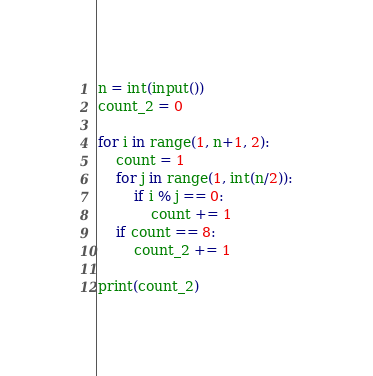<code> <loc_0><loc_0><loc_500><loc_500><_Python_>n = int(input())
count_2 = 0

for i in range(1, n+1, 2):
    count = 1
    for j in range(1, int(n/2)):
        if i % j == 0:
            count += 1
    if count == 8:
        count_2 += 1

print(count_2)</code> 